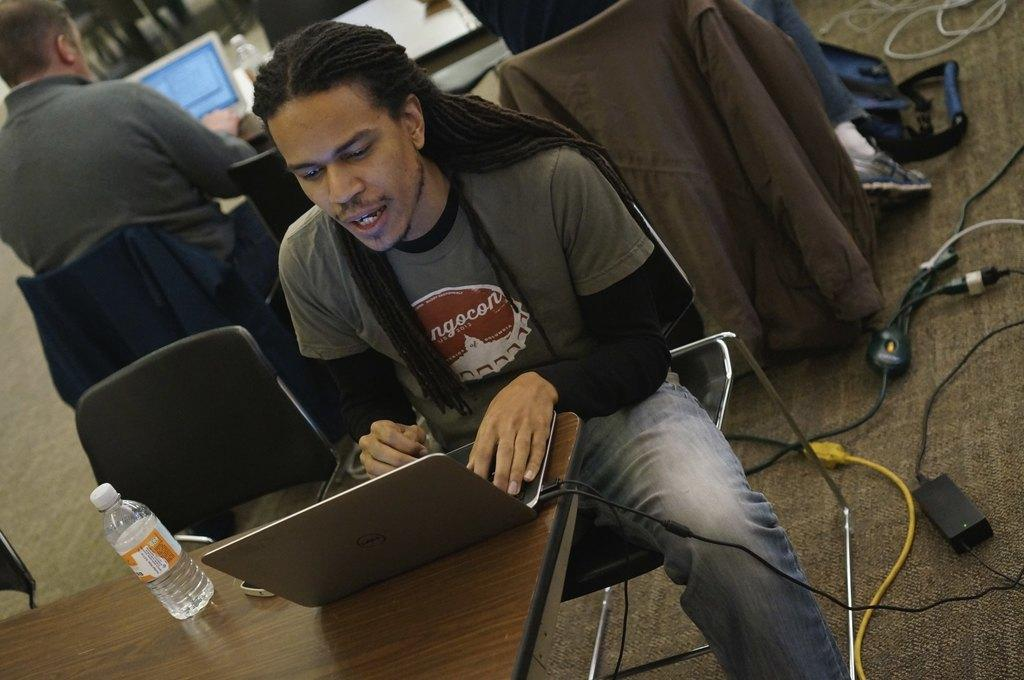What is the man in the image doing? The man is sitting on a chair in the image. What is located behind the man? The man is in front of a table. What can be seen on the table? There is a glass bottle and a laptop on the table. Are there any other objects on the table? Yes, there are other objects on the table. What letters did the man receive from his mom in the image? There is no mention of letters or the man's mom in the image. Can you see a gate in the image? There is no gate present in the image. 